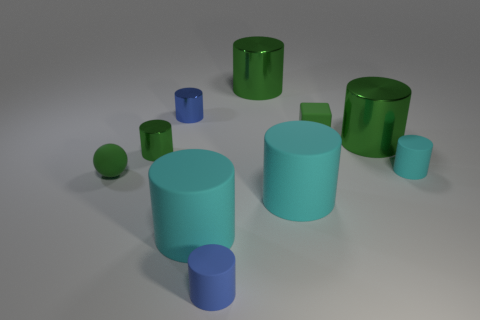Does the tiny green shiny object have the same shape as the small metallic object that is behind the tiny green metallic cylinder?
Offer a terse response. Yes. What number of blue matte cylinders are the same size as the sphere?
Your answer should be very brief. 1. There is a small cyan object that is the same shape as the tiny blue metallic object; what material is it?
Give a very brief answer. Rubber. There is a metal thing to the right of the small green matte block; is its color the same as the small cylinder in front of the sphere?
Offer a terse response. No. There is a cyan object that is left of the blue rubber thing; what shape is it?
Your answer should be compact. Cylinder. There is a tiny blue object that is the same material as the tiny cyan cylinder; what is its shape?
Your response must be concise. Cylinder. Does the cyan thing that is on the right side of the green block have the same size as the small ball?
Offer a terse response. Yes. How many things are objects in front of the small cyan thing or blue cylinders right of the tiny blue shiny object?
Provide a succinct answer. 4. There is a large metal cylinder that is in front of the green block; is it the same color as the small cube?
Keep it short and to the point. Yes. What number of metallic objects are small objects or large things?
Provide a short and direct response. 4. 